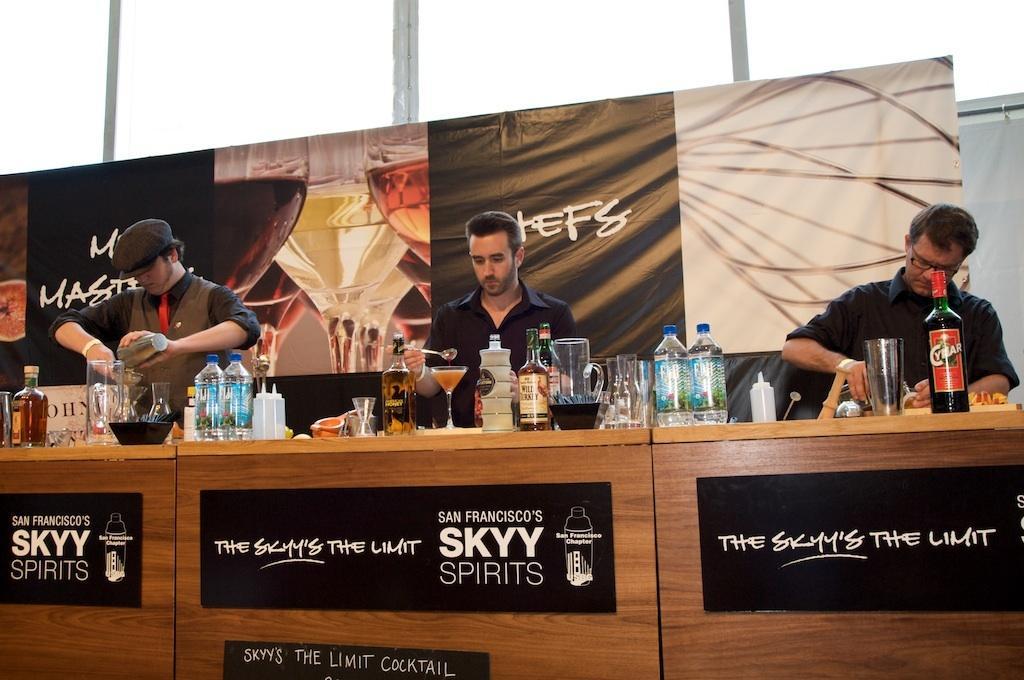Can you describe this image briefly? This is a picture of three people who are behind the desk and on the desk we have some jars, glasses, bottles and some things. 